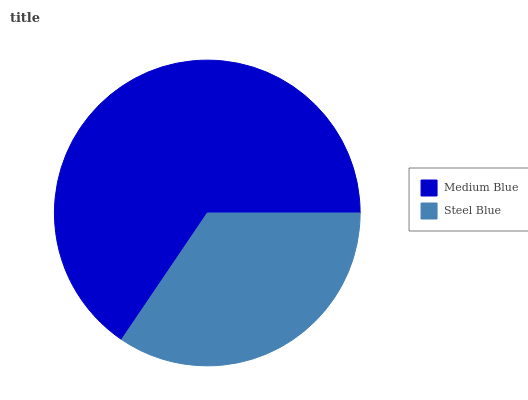Is Steel Blue the minimum?
Answer yes or no. Yes. Is Medium Blue the maximum?
Answer yes or no. Yes. Is Steel Blue the maximum?
Answer yes or no. No. Is Medium Blue greater than Steel Blue?
Answer yes or no. Yes. Is Steel Blue less than Medium Blue?
Answer yes or no. Yes. Is Steel Blue greater than Medium Blue?
Answer yes or no. No. Is Medium Blue less than Steel Blue?
Answer yes or no. No. Is Medium Blue the high median?
Answer yes or no. Yes. Is Steel Blue the low median?
Answer yes or no. Yes. Is Steel Blue the high median?
Answer yes or no. No. Is Medium Blue the low median?
Answer yes or no. No. 